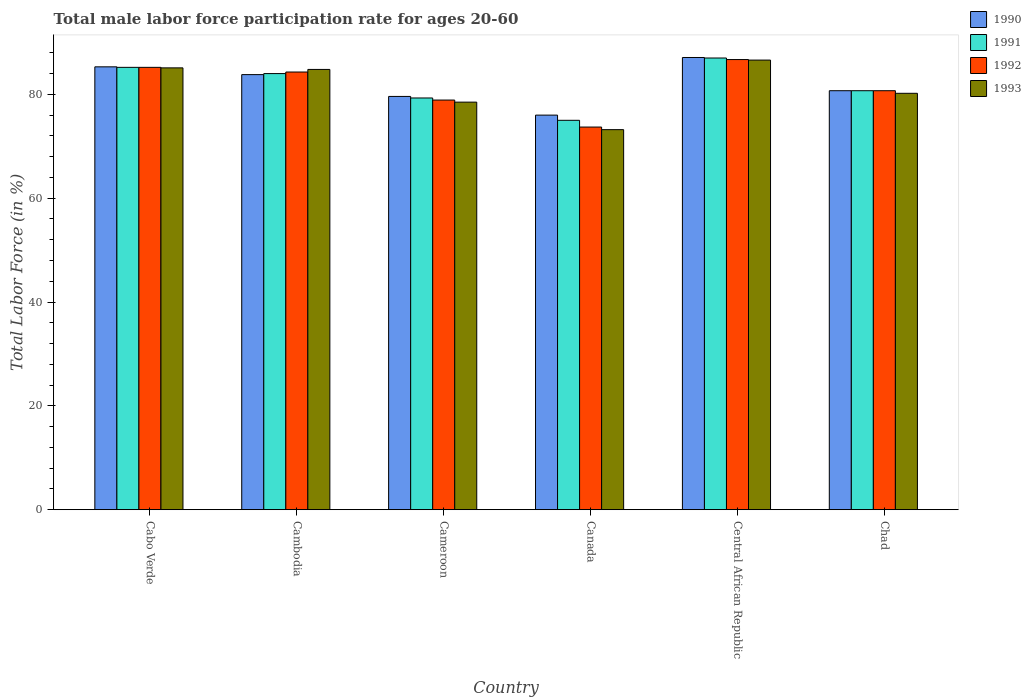How many different coloured bars are there?
Ensure brevity in your answer.  4. Are the number of bars on each tick of the X-axis equal?
Give a very brief answer. Yes. How many bars are there on the 4th tick from the left?
Ensure brevity in your answer.  4. How many bars are there on the 5th tick from the right?
Provide a succinct answer. 4. What is the label of the 4th group of bars from the left?
Provide a short and direct response. Canada. What is the male labor force participation rate in 1991 in Central African Republic?
Give a very brief answer. 87. Across all countries, what is the maximum male labor force participation rate in 1992?
Provide a succinct answer. 86.7. Across all countries, what is the minimum male labor force participation rate in 1992?
Make the answer very short. 73.7. In which country was the male labor force participation rate in 1992 maximum?
Provide a succinct answer. Central African Republic. What is the total male labor force participation rate in 1991 in the graph?
Make the answer very short. 491.2. What is the difference between the male labor force participation rate in 1992 in Cameroon and that in Chad?
Provide a short and direct response. -1.8. What is the difference between the male labor force participation rate in 1990 in Chad and the male labor force participation rate in 1992 in Cambodia?
Offer a terse response. -3.6. What is the average male labor force participation rate in 1992 per country?
Your answer should be very brief. 81.58. What is the difference between the male labor force participation rate of/in 1991 and male labor force participation rate of/in 1993 in Cameroon?
Your answer should be very brief. 0.8. What is the ratio of the male labor force participation rate in 1993 in Central African Republic to that in Chad?
Your answer should be compact. 1.08. Is the male labor force participation rate in 1990 in Cabo Verde less than that in Canada?
Make the answer very short. No. What is the difference between the highest and the second highest male labor force participation rate in 1990?
Offer a terse response. -1.5. What is the difference between the highest and the lowest male labor force participation rate in 1992?
Your answer should be compact. 13. Is the sum of the male labor force participation rate in 1993 in Canada and Central African Republic greater than the maximum male labor force participation rate in 1992 across all countries?
Keep it short and to the point. Yes. What does the 1st bar from the right in Cameroon represents?
Ensure brevity in your answer.  1993. Is it the case that in every country, the sum of the male labor force participation rate in 1990 and male labor force participation rate in 1992 is greater than the male labor force participation rate in 1993?
Offer a terse response. Yes. How many bars are there?
Your answer should be very brief. 24. Are all the bars in the graph horizontal?
Your answer should be compact. No. Does the graph contain grids?
Give a very brief answer. No. What is the title of the graph?
Ensure brevity in your answer.  Total male labor force participation rate for ages 20-60. Does "1980" appear as one of the legend labels in the graph?
Provide a succinct answer. No. What is the label or title of the X-axis?
Keep it short and to the point. Country. What is the Total Labor Force (in %) in 1990 in Cabo Verde?
Offer a very short reply. 85.3. What is the Total Labor Force (in %) in 1991 in Cabo Verde?
Make the answer very short. 85.2. What is the Total Labor Force (in %) of 1992 in Cabo Verde?
Ensure brevity in your answer.  85.2. What is the Total Labor Force (in %) in 1993 in Cabo Verde?
Your response must be concise. 85.1. What is the Total Labor Force (in %) of 1990 in Cambodia?
Ensure brevity in your answer.  83.8. What is the Total Labor Force (in %) in 1992 in Cambodia?
Make the answer very short. 84.3. What is the Total Labor Force (in %) in 1993 in Cambodia?
Offer a terse response. 84.8. What is the Total Labor Force (in %) of 1990 in Cameroon?
Your answer should be compact. 79.6. What is the Total Labor Force (in %) of 1991 in Cameroon?
Make the answer very short. 79.3. What is the Total Labor Force (in %) in 1992 in Cameroon?
Provide a succinct answer. 78.9. What is the Total Labor Force (in %) in 1993 in Cameroon?
Offer a terse response. 78.5. What is the Total Labor Force (in %) in 1990 in Canada?
Your answer should be very brief. 76. What is the Total Labor Force (in %) of 1991 in Canada?
Give a very brief answer. 75. What is the Total Labor Force (in %) of 1992 in Canada?
Give a very brief answer. 73.7. What is the Total Labor Force (in %) of 1993 in Canada?
Your answer should be very brief. 73.2. What is the Total Labor Force (in %) of 1990 in Central African Republic?
Keep it short and to the point. 87.1. What is the Total Labor Force (in %) in 1991 in Central African Republic?
Provide a short and direct response. 87. What is the Total Labor Force (in %) of 1992 in Central African Republic?
Your answer should be compact. 86.7. What is the Total Labor Force (in %) in 1993 in Central African Republic?
Your answer should be compact. 86.6. What is the Total Labor Force (in %) of 1990 in Chad?
Provide a short and direct response. 80.7. What is the Total Labor Force (in %) in 1991 in Chad?
Provide a succinct answer. 80.7. What is the Total Labor Force (in %) in 1992 in Chad?
Provide a short and direct response. 80.7. What is the Total Labor Force (in %) of 1993 in Chad?
Offer a terse response. 80.2. Across all countries, what is the maximum Total Labor Force (in %) in 1990?
Give a very brief answer. 87.1. Across all countries, what is the maximum Total Labor Force (in %) of 1991?
Your answer should be very brief. 87. Across all countries, what is the maximum Total Labor Force (in %) in 1992?
Provide a succinct answer. 86.7. Across all countries, what is the maximum Total Labor Force (in %) in 1993?
Ensure brevity in your answer.  86.6. Across all countries, what is the minimum Total Labor Force (in %) of 1990?
Your answer should be very brief. 76. Across all countries, what is the minimum Total Labor Force (in %) in 1991?
Offer a very short reply. 75. Across all countries, what is the minimum Total Labor Force (in %) of 1992?
Your answer should be very brief. 73.7. Across all countries, what is the minimum Total Labor Force (in %) of 1993?
Ensure brevity in your answer.  73.2. What is the total Total Labor Force (in %) of 1990 in the graph?
Keep it short and to the point. 492.5. What is the total Total Labor Force (in %) in 1991 in the graph?
Keep it short and to the point. 491.2. What is the total Total Labor Force (in %) of 1992 in the graph?
Provide a succinct answer. 489.5. What is the total Total Labor Force (in %) in 1993 in the graph?
Make the answer very short. 488.4. What is the difference between the Total Labor Force (in %) of 1991 in Cabo Verde and that in Cambodia?
Make the answer very short. 1.2. What is the difference between the Total Labor Force (in %) in 1993 in Cabo Verde and that in Cambodia?
Offer a terse response. 0.3. What is the difference between the Total Labor Force (in %) of 1990 in Cabo Verde and that in Cameroon?
Your answer should be compact. 5.7. What is the difference between the Total Labor Force (in %) in 1991 in Cabo Verde and that in Cameroon?
Offer a terse response. 5.9. What is the difference between the Total Labor Force (in %) in 1992 in Cabo Verde and that in Cameroon?
Your answer should be very brief. 6.3. What is the difference between the Total Labor Force (in %) in 1993 in Cabo Verde and that in Cameroon?
Your answer should be very brief. 6.6. What is the difference between the Total Labor Force (in %) of 1993 in Cabo Verde and that in Canada?
Your answer should be compact. 11.9. What is the difference between the Total Labor Force (in %) of 1991 in Cabo Verde and that in Central African Republic?
Your answer should be compact. -1.8. What is the difference between the Total Labor Force (in %) of 1993 in Cabo Verde and that in Central African Republic?
Offer a terse response. -1.5. What is the difference between the Total Labor Force (in %) in 1990 in Cabo Verde and that in Chad?
Offer a terse response. 4.6. What is the difference between the Total Labor Force (in %) of 1991 in Cabo Verde and that in Chad?
Provide a short and direct response. 4.5. What is the difference between the Total Labor Force (in %) in 1992 in Cabo Verde and that in Chad?
Make the answer very short. 4.5. What is the difference between the Total Labor Force (in %) of 1990 in Cambodia and that in Cameroon?
Provide a short and direct response. 4.2. What is the difference between the Total Labor Force (in %) of 1992 in Cambodia and that in Cameroon?
Provide a short and direct response. 5.4. What is the difference between the Total Labor Force (in %) of 1993 in Cambodia and that in Cameroon?
Make the answer very short. 6.3. What is the difference between the Total Labor Force (in %) in 1990 in Cambodia and that in Canada?
Provide a short and direct response. 7.8. What is the difference between the Total Labor Force (in %) of 1991 in Cambodia and that in Canada?
Your answer should be very brief. 9. What is the difference between the Total Labor Force (in %) of 1992 in Cambodia and that in Canada?
Make the answer very short. 10.6. What is the difference between the Total Labor Force (in %) of 1992 in Cambodia and that in Central African Republic?
Your answer should be very brief. -2.4. What is the difference between the Total Labor Force (in %) in 1993 in Cambodia and that in Chad?
Offer a very short reply. 4.6. What is the difference between the Total Labor Force (in %) in 1990 in Cameroon and that in Canada?
Offer a very short reply. 3.6. What is the difference between the Total Labor Force (in %) of 1992 in Cameroon and that in Canada?
Make the answer very short. 5.2. What is the difference between the Total Labor Force (in %) of 1990 in Cameroon and that in Central African Republic?
Make the answer very short. -7.5. What is the difference between the Total Labor Force (in %) of 1992 in Cameroon and that in Central African Republic?
Make the answer very short. -7.8. What is the difference between the Total Labor Force (in %) of 1993 in Cameroon and that in Central African Republic?
Offer a very short reply. -8.1. What is the difference between the Total Labor Force (in %) of 1991 in Cameroon and that in Chad?
Ensure brevity in your answer.  -1.4. What is the difference between the Total Labor Force (in %) of 1991 in Canada and that in Central African Republic?
Offer a very short reply. -12. What is the difference between the Total Labor Force (in %) in 1993 in Canada and that in Central African Republic?
Offer a very short reply. -13.4. What is the difference between the Total Labor Force (in %) of 1990 in Canada and that in Chad?
Your answer should be very brief. -4.7. What is the difference between the Total Labor Force (in %) of 1992 in Central African Republic and that in Chad?
Your response must be concise. 6. What is the difference between the Total Labor Force (in %) in 1993 in Central African Republic and that in Chad?
Your response must be concise. 6.4. What is the difference between the Total Labor Force (in %) in 1990 in Cabo Verde and the Total Labor Force (in %) in 1993 in Cambodia?
Keep it short and to the point. 0.5. What is the difference between the Total Labor Force (in %) in 1992 in Cabo Verde and the Total Labor Force (in %) in 1993 in Cambodia?
Your answer should be very brief. 0.4. What is the difference between the Total Labor Force (in %) of 1990 in Cabo Verde and the Total Labor Force (in %) of 1991 in Cameroon?
Your answer should be very brief. 6. What is the difference between the Total Labor Force (in %) in 1990 in Cabo Verde and the Total Labor Force (in %) in 1992 in Cameroon?
Ensure brevity in your answer.  6.4. What is the difference between the Total Labor Force (in %) of 1991 in Cabo Verde and the Total Labor Force (in %) of 1992 in Cameroon?
Provide a succinct answer. 6.3. What is the difference between the Total Labor Force (in %) in 1991 in Cabo Verde and the Total Labor Force (in %) in 1993 in Cameroon?
Your answer should be very brief. 6.7. What is the difference between the Total Labor Force (in %) in 1992 in Cabo Verde and the Total Labor Force (in %) in 1993 in Cameroon?
Provide a short and direct response. 6.7. What is the difference between the Total Labor Force (in %) of 1990 in Cabo Verde and the Total Labor Force (in %) of 1992 in Canada?
Give a very brief answer. 11.6. What is the difference between the Total Labor Force (in %) in 1990 in Cabo Verde and the Total Labor Force (in %) in 1993 in Canada?
Your answer should be compact. 12.1. What is the difference between the Total Labor Force (in %) of 1991 in Cabo Verde and the Total Labor Force (in %) of 1992 in Canada?
Give a very brief answer. 11.5. What is the difference between the Total Labor Force (in %) of 1991 in Cabo Verde and the Total Labor Force (in %) of 1993 in Canada?
Ensure brevity in your answer.  12. What is the difference between the Total Labor Force (in %) in 1990 in Cabo Verde and the Total Labor Force (in %) in 1991 in Central African Republic?
Your response must be concise. -1.7. What is the difference between the Total Labor Force (in %) in 1990 in Cabo Verde and the Total Labor Force (in %) in 1992 in Central African Republic?
Give a very brief answer. -1.4. What is the difference between the Total Labor Force (in %) in 1991 in Cabo Verde and the Total Labor Force (in %) in 1992 in Central African Republic?
Provide a short and direct response. -1.5. What is the difference between the Total Labor Force (in %) in 1990 in Cabo Verde and the Total Labor Force (in %) in 1991 in Chad?
Your response must be concise. 4.6. What is the difference between the Total Labor Force (in %) of 1992 in Cabo Verde and the Total Labor Force (in %) of 1993 in Chad?
Provide a short and direct response. 5. What is the difference between the Total Labor Force (in %) in 1990 in Cambodia and the Total Labor Force (in %) in 1992 in Cameroon?
Offer a terse response. 4.9. What is the difference between the Total Labor Force (in %) of 1990 in Cambodia and the Total Labor Force (in %) of 1993 in Cameroon?
Offer a terse response. 5.3. What is the difference between the Total Labor Force (in %) of 1991 in Cambodia and the Total Labor Force (in %) of 1992 in Cameroon?
Offer a terse response. 5.1. What is the difference between the Total Labor Force (in %) in 1992 in Cambodia and the Total Labor Force (in %) in 1993 in Cameroon?
Keep it short and to the point. 5.8. What is the difference between the Total Labor Force (in %) in 1990 in Cambodia and the Total Labor Force (in %) in 1993 in Canada?
Give a very brief answer. 10.6. What is the difference between the Total Labor Force (in %) in 1991 in Cambodia and the Total Labor Force (in %) in 1993 in Canada?
Make the answer very short. 10.8. What is the difference between the Total Labor Force (in %) in 1990 in Cambodia and the Total Labor Force (in %) in 1992 in Central African Republic?
Give a very brief answer. -2.9. What is the difference between the Total Labor Force (in %) of 1991 in Cambodia and the Total Labor Force (in %) of 1992 in Central African Republic?
Provide a succinct answer. -2.7. What is the difference between the Total Labor Force (in %) of 1990 in Cambodia and the Total Labor Force (in %) of 1993 in Chad?
Keep it short and to the point. 3.6. What is the difference between the Total Labor Force (in %) in 1992 in Cambodia and the Total Labor Force (in %) in 1993 in Chad?
Keep it short and to the point. 4.1. What is the difference between the Total Labor Force (in %) of 1990 in Cameroon and the Total Labor Force (in %) of 1991 in Central African Republic?
Give a very brief answer. -7.4. What is the difference between the Total Labor Force (in %) of 1990 in Cameroon and the Total Labor Force (in %) of 1992 in Central African Republic?
Offer a very short reply. -7.1. What is the difference between the Total Labor Force (in %) in 1990 in Cameroon and the Total Labor Force (in %) in 1993 in Central African Republic?
Your answer should be compact. -7. What is the difference between the Total Labor Force (in %) of 1991 in Cameroon and the Total Labor Force (in %) of 1993 in Central African Republic?
Ensure brevity in your answer.  -7.3. What is the difference between the Total Labor Force (in %) of 1990 in Cameroon and the Total Labor Force (in %) of 1992 in Chad?
Give a very brief answer. -1.1. What is the difference between the Total Labor Force (in %) of 1991 in Cameroon and the Total Labor Force (in %) of 1992 in Chad?
Your answer should be very brief. -1.4. What is the difference between the Total Labor Force (in %) in 1991 in Cameroon and the Total Labor Force (in %) in 1993 in Chad?
Make the answer very short. -0.9. What is the difference between the Total Labor Force (in %) of 1990 in Canada and the Total Labor Force (in %) of 1991 in Central African Republic?
Provide a short and direct response. -11. What is the difference between the Total Labor Force (in %) in 1990 in Canada and the Total Labor Force (in %) in 1992 in Central African Republic?
Your answer should be very brief. -10.7. What is the difference between the Total Labor Force (in %) in 1990 in Canada and the Total Labor Force (in %) in 1993 in Central African Republic?
Make the answer very short. -10.6. What is the difference between the Total Labor Force (in %) of 1991 in Canada and the Total Labor Force (in %) of 1992 in Central African Republic?
Make the answer very short. -11.7. What is the difference between the Total Labor Force (in %) of 1991 in Canada and the Total Labor Force (in %) of 1993 in Central African Republic?
Offer a very short reply. -11.6. What is the difference between the Total Labor Force (in %) in 1992 in Canada and the Total Labor Force (in %) in 1993 in Central African Republic?
Provide a succinct answer. -12.9. What is the difference between the Total Labor Force (in %) in 1990 in Canada and the Total Labor Force (in %) in 1991 in Chad?
Your response must be concise. -4.7. What is the difference between the Total Labor Force (in %) of 1990 in Canada and the Total Labor Force (in %) of 1992 in Chad?
Your response must be concise. -4.7. What is the difference between the Total Labor Force (in %) in 1991 in Central African Republic and the Total Labor Force (in %) in 1993 in Chad?
Offer a very short reply. 6.8. What is the difference between the Total Labor Force (in %) in 1992 in Central African Republic and the Total Labor Force (in %) in 1993 in Chad?
Offer a very short reply. 6.5. What is the average Total Labor Force (in %) of 1990 per country?
Keep it short and to the point. 82.08. What is the average Total Labor Force (in %) of 1991 per country?
Keep it short and to the point. 81.87. What is the average Total Labor Force (in %) of 1992 per country?
Offer a terse response. 81.58. What is the average Total Labor Force (in %) of 1993 per country?
Provide a succinct answer. 81.4. What is the difference between the Total Labor Force (in %) of 1990 and Total Labor Force (in %) of 1992 in Cabo Verde?
Keep it short and to the point. 0.1. What is the difference between the Total Labor Force (in %) in 1990 and Total Labor Force (in %) in 1993 in Cabo Verde?
Make the answer very short. 0.2. What is the difference between the Total Labor Force (in %) in 1992 and Total Labor Force (in %) in 1993 in Cabo Verde?
Your answer should be compact. 0.1. What is the difference between the Total Labor Force (in %) in 1990 and Total Labor Force (in %) in 1991 in Cambodia?
Offer a very short reply. -0.2. What is the difference between the Total Labor Force (in %) in 1990 and Total Labor Force (in %) in 1992 in Cambodia?
Ensure brevity in your answer.  -0.5. What is the difference between the Total Labor Force (in %) of 1992 and Total Labor Force (in %) of 1993 in Cambodia?
Your response must be concise. -0.5. What is the difference between the Total Labor Force (in %) of 1990 and Total Labor Force (in %) of 1991 in Cameroon?
Your response must be concise. 0.3. What is the difference between the Total Labor Force (in %) in 1990 and Total Labor Force (in %) in 1993 in Cameroon?
Keep it short and to the point. 1.1. What is the difference between the Total Labor Force (in %) in 1992 and Total Labor Force (in %) in 1993 in Cameroon?
Ensure brevity in your answer.  0.4. What is the difference between the Total Labor Force (in %) of 1990 and Total Labor Force (in %) of 1991 in Canada?
Ensure brevity in your answer.  1. What is the difference between the Total Labor Force (in %) of 1990 and Total Labor Force (in %) of 1992 in Canada?
Provide a succinct answer. 2.3. What is the difference between the Total Labor Force (in %) of 1990 and Total Labor Force (in %) of 1993 in Canada?
Your response must be concise. 2.8. What is the difference between the Total Labor Force (in %) in 1991 and Total Labor Force (in %) in 1992 in Canada?
Provide a succinct answer. 1.3. What is the difference between the Total Labor Force (in %) of 1991 and Total Labor Force (in %) of 1993 in Canada?
Make the answer very short. 1.8. What is the difference between the Total Labor Force (in %) in 1991 and Total Labor Force (in %) in 1992 in Central African Republic?
Provide a short and direct response. 0.3. What is the difference between the Total Labor Force (in %) in 1991 and Total Labor Force (in %) in 1993 in Central African Republic?
Make the answer very short. 0.4. What is the difference between the Total Labor Force (in %) in 1992 and Total Labor Force (in %) in 1993 in Central African Republic?
Offer a terse response. 0.1. What is the difference between the Total Labor Force (in %) of 1990 and Total Labor Force (in %) of 1991 in Chad?
Provide a succinct answer. 0. What is the difference between the Total Labor Force (in %) in 1990 and Total Labor Force (in %) in 1993 in Chad?
Provide a short and direct response. 0.5. What is the difference between the Total Labor Force (in %) in 1991 and Total Labor Force (in %) in 1993 in Chad?
Offer a very short reply. 0.5. What is the ratio of the Total Labor Force (in %) in 1990 in Cabo Verde to that in Cambodia?
Offer a terse response. 1.02. What is the ratio of the Total Labor Force (in %) in 1991 in Cabo Verde to that in Cambodia?
Your response must be concise. 1.01. What is the ratio of the Total Labor Force (in %) of 1992 in Cabo Verde to that in Cambodia?
Provide a short and direct response. 1.01. What is the ratio of the Total Labor Force (in %) in 1990 in Cabo Verde to that in Cameroon?
Make the answer very short. 1.07. What is the ratio of the Total Labor Force (in %) in 1991 in Cabo Verde to that in Cameroon?
Ensure brevity in your answer.  1.07. What is the ratio of the Total Labor Force (in %) of 1992 in Cabo Verde to that in Cameroon?
Your response must be concise. 1.08. What is the ratio of the Total Labor Force (in %) in 1993 in Cabo Verde to that in Cameroon?
Provide a succinct answer. 1.08. What is the ratio of the Total Labor Force (in %) in 1990 in Cabo Verde to that in Canada?
Offer a terse response. 1.12. What is the ratio of the Total Labor Force (in %) in 1991 in Cabo Verde to that in Canada?
Your response must be concise. 1.14. What is the ratio of the Total Labor Force (in %) of 1992 in Cabo Verde to that in Canada?
Offer a terse response. 1.16. What is the ratio of the Total Labor Force (in %) in 1993 in Cabo Verde to that in Canada?
Your answer should be compact. 1.16. What is the ratio of the Total Labor Force (in %) in 1990 in Cabo Verde to that in Central African Republic?
Offer a very short reply. 0.98. What is the ratio of the Total Labor Force (in %) of 1991 in Cabo Verde to that in Central African Republic?
Ensure brevity in your answer.  0.98. What is the ratio of the Total Labor Force (in %) of 1992 in Cabo Verde to that in Central African Republic?
Offer a terse response. 0.98. What is the ratio of the Total Labor Force (in %) of 1993 in Cabo Verde to that in Central African Republic?
Provide a short and direct response. 0.98. What is the ratio of the Total Labor Force (in %) in 1990 in Cabo Verde to that in Chad?
Give a very brief answer. 1.06. What is the ratio of the Total Labor Force (in %) of 1991 in Cabo Verde to that in Chad?
Your answer should be compact. 1.06. What is the ratio of the Total Labor Force (in %) in 1992 in Cabo Verde to that in Chad?
Keep it short and to the point. 1.06. What is the ratio of the Total Labor Force (in %) of 1993 in Cabo Verde to that in Chad?
Provide a succinct answer. 1.06. What is the ratio of the Total Labor Force (in %) in 1990 in Cambodia to that in Cameroon?
Your response must be concise. 1.05. What is the ratio of the Total Labor Force (in %) of 1991 in Cambodia to that in Cameroon?
Keep it short and to the point. 1.06. What is the ratio of the Total Labor Force (in %) in 1992 in Cambodia to that in Cameroon?
Your answer should be compact. 1.07. What is the ratio of the Total Labor Force (in %) of 1993 in Cambodia to that in Cameroon?
Your response must be concise. 1.08. What is the ratio of the Total Labor Force (in %) of 1990 in Cambodia to that in Canada?
Give a very brief answer. 1.1. What is the ratio of the Total Labor Force (in %) in 1991 in Cambodia to that in Canada?
Offer a very short reply. 1.12. What is the ratio of the Total Labor Force (in %) in 1992 in Cambodia to that in Canada?
Provide a succinct answer. 1.14. What is the ratio of the Total Labor Force (in %) of 1993 in Cambodia to that in Canada?
Provide a succinct answer. 1.16. What is the ratio of the Total Labor Force (in %) in 1990 in Cambodia to that in Central African Republic?
Offer a very short reply. 0.96. What is the ratio of the Total Labor Force (in %) of 1991 in Cambodia to that in Central African Republic?
Offer a terse response. 0.97. What is the ratio of the Total Labor Force (in %) in 1992 in Cambodia to that in Central African Republic?
Offer a terse response. 0.97. What is the ratio of the Total Labor Force (in %) of 1993 in Cambodia to that in Central African Republic?
Give a very brief answer. 0.98. What is the ratio of the Total Labor Force (in %) of 1990 in Cambodia to that in Chad?
Your answer should be compact. 1.04. What is the ratio of the Total Labor Force (in %) in 1991 in Cambodia to that in Chad?
Offer a terse response. 1.04. What is the ratio of the Total Labor Force (in %) of 1992 in Cambodia to that in Chad?
Your answer should be compact. 1.04. What is the ratio of the Total Labor Force (in %) of 1993 in Cambodia to that in Chad?
Offer a terse response. 1.06. What is the ratio of the Total Labor Force (in %) in 1990 in Cameroon to that in Canada?
Provide a succinct answer. 1.05. What is the ratio of the Total Labor Force (in %) in 1991 in Cameroon to that in Canada?
Keep it short and to the point. 1.06. What is the ratio of the Total Labor Force (in %) in 1992 in Cameroon to that in Canada?
Provide a succinct answer. 1.07. What is the ratio of the Total Labor Force (in %) of 1993 in Cameroon to that in Canada?
Keep it short and to the point. 1.07. What is the ratio of the Total Labor Force (in %) in 1990 in Cameroon to that in Central African Republic?
Your response must be concise. 0.91. What is the ratio of the Total Labor Force (in %) of 1991 in Cameroon to that in Central African Republic?
Ensure brevity in your answer.  0.91. What is the ratio of the Total Labor Force (in %) of 1992 in Cameroon to that in Central African Republic?
Offer a very short reply. 0.91. What is the ratio of the Total Labor Force (in %) of 1993 in Cameroon to that in Central African Republic?
Make the answer very short. 0.91. What is the ratio of the Total Labor Force (in %) in 1990 in Cameroon to that in Chad?
Provide a short and direct response. 0.99. What is the ratio of the Total Labor Force (in %) in 1991 in Cameroon to that in Chad?
Give a very brief answer. 0.98. What is the ratio of the Total Labor Force (in %) in 1992 in Cameroon to that in Chad?
Ensure brevity in your answer.  0.98. What is the ratio of the Total Labor Force (in %) of 1993 in Cameroon to that in Chad?
Your response must be concise. 0.98. What is the ratio of the Total Labor Force (in %) of 1990 in Canada to that in Central African Republic?
Offer a very short reply. 0.87. What is the ratio of the Total Labor Force (in %) of 1991 in Canada to that in Central African Republic?
Keep it short and to the point. 0.86. What is the ratio of the Total Labor Force (in %) in 1992 in Canada to that in Central African Republic?
Keep it short and to the point. 0.85. What is the ratio of the Total Labor Force (in %) of 1993 in Canada to that in Central African Republic?
Offer a terse response. 0.85. What is the ratio of the Total Labor Force (in %) in 1990 in Canada to that in Chad?
Your response must be concise. 0.94. What is the ratio of the Total Labor Force (in %) in 1991 in Canada to that in Chad?
Provide a short and direct response. 0.93. What is the ratio of the Total Labor Force (in %) of 1992 in Canada to that in Chad?
Give a very brief answer. 0.91. What is the ratio of the Total Labor Force (in %) in 1993 in Canada to that in Chad?
Provide a succinct answer. 0.91. What is the ratio of the Total Labor Force (in %) of 1990 in Central African Republic to that in Chad?
Give a very brief answer. 1.08. What is the ratio of the Total Labor Force (in %) of 1991 in Central African Republic to that in Chad?
Your answer should be very brief. 1.08. What is the ratio of the Total Labor Force (in %) of 1992 in Central African Republic to that in Chad?
Your answer should be very brief. 1.07. What is the ratio of the Total Labor Force (in %) of 1993 in Central African Republic to that in Chad?
Your answer should be very brief. 1.08. What is the difference between the highest and the second highest Total Labor Force (in %) of 1990?
Offer a terse response. 1.8. What is the difference between the highest and the second highest Total Labor Force (in %) in 1991?
Provide a short and direct response. 1.8. What is the difference between the highest and the second highest Total Labor Force (in %) in 1992?
Make the answer very short. 1.5. What is the difference between the highest and the lowest Total Labor Force (in %) of 1993?
Your answer should be compact. 13.4. 